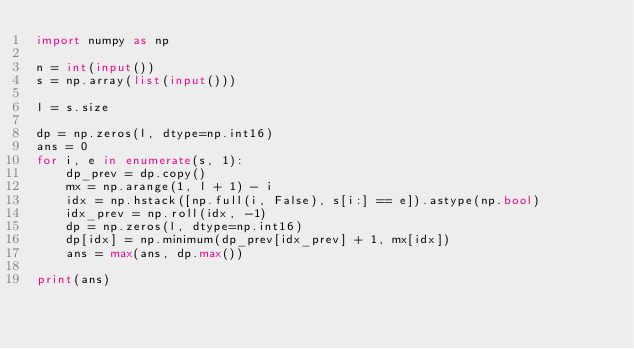Convert code to text. <code><loc_0><loc_0><loc_500><loc_500><_Python_>import numpy as np

n = int(input())
s = np.array(list(input()))

l = s.size

dp = np.zeros(l, dtype=np.int16)
ans = 0
for i, e in enumerate(s, 1):
    dp_prev = dp.copy()
    mx = np.arange(1, l + 1) - i
    idx = np.hstack([np.full(i, False), s[i:] == e]).astype(np.bool)
    idx_prev = np.roll(idx, -1)
    dp = np.zeros(l, dtype=np.int16)
    dp[idx] = np.minimum(dp_prev[idx_prev] + 1, mx[idx])
    ans = max(ans, dp.max())

print(ans)
</code> 